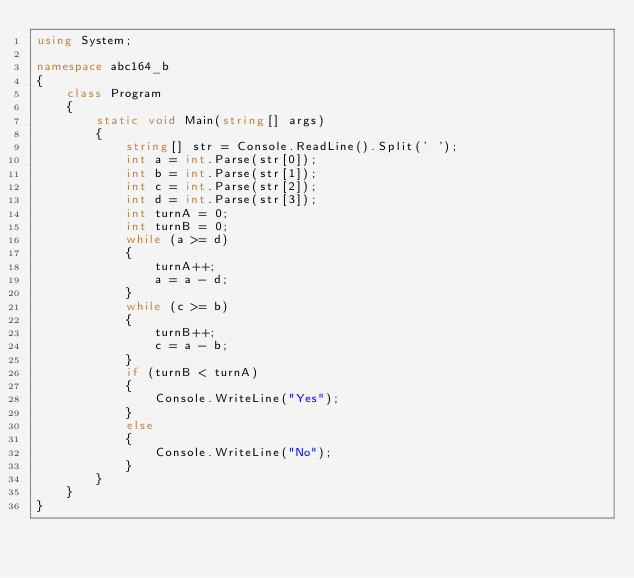Convert code to text. <code><loc_0><loc_0><loc_500><loc_500><_C#_>using System;

namespace abc164_b
{
    class Program
    {
        static void Main(string[] args)
        {
            string[] str = Console.ReadLine().Split(' ');
            int a = int.Parse(str[0]);
            int b = int.Parse(str[1]);
            int c = int.Parse(str[2]);
            int d = int.Parse(str[3]);
            int turnA = 0;
            int turnB = 0;
            while (a >= d)
            {
                turnA++;
                a = a - d;
            }
            while (c >= b)
            {
                turnB++;
                c = a - b;
            }
            if (turnB < turnA)
            {
                Console.WriteLine("Yes");
            }
            else
            {
                Console.WriteLine("No");
            }
        }
    }
}
</code> 